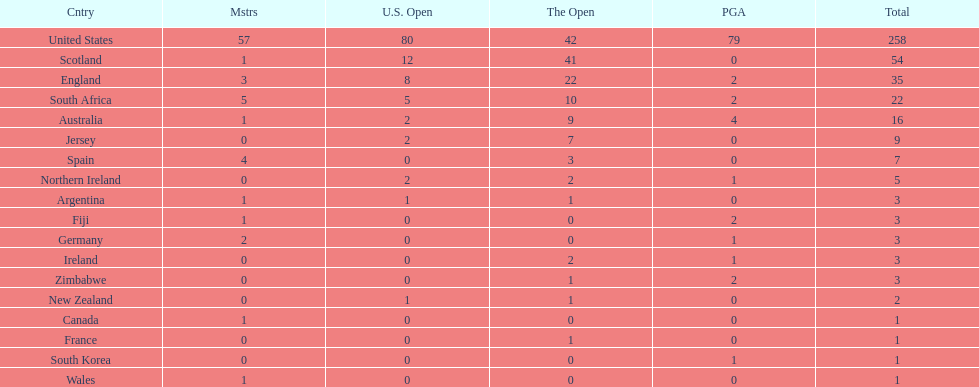How many total championships does spain have? 7. 